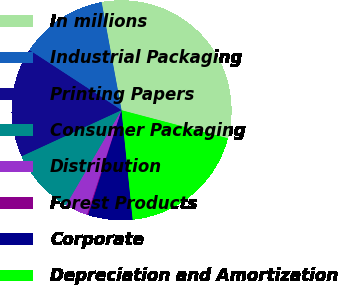Convert chart. <chart><loc_0><loc_0><loc_500><loc_500><pie_chart><fcel>In millions<fcel>Industrial Packaging<fcel>Printing Papers<fcel>Consumer Packaging<fcel>Distribution<fcel>Forest Products<fcel>Corporate<fcel>Depreciation and Amortization<nl><fcel>32.01%<fcel>12.9%<fcel>16.08%<fcel>9.71%<fcel>3.34%<fcel>0.16%<fcel>6.53%<fcel>19.27%<nl></chart> 